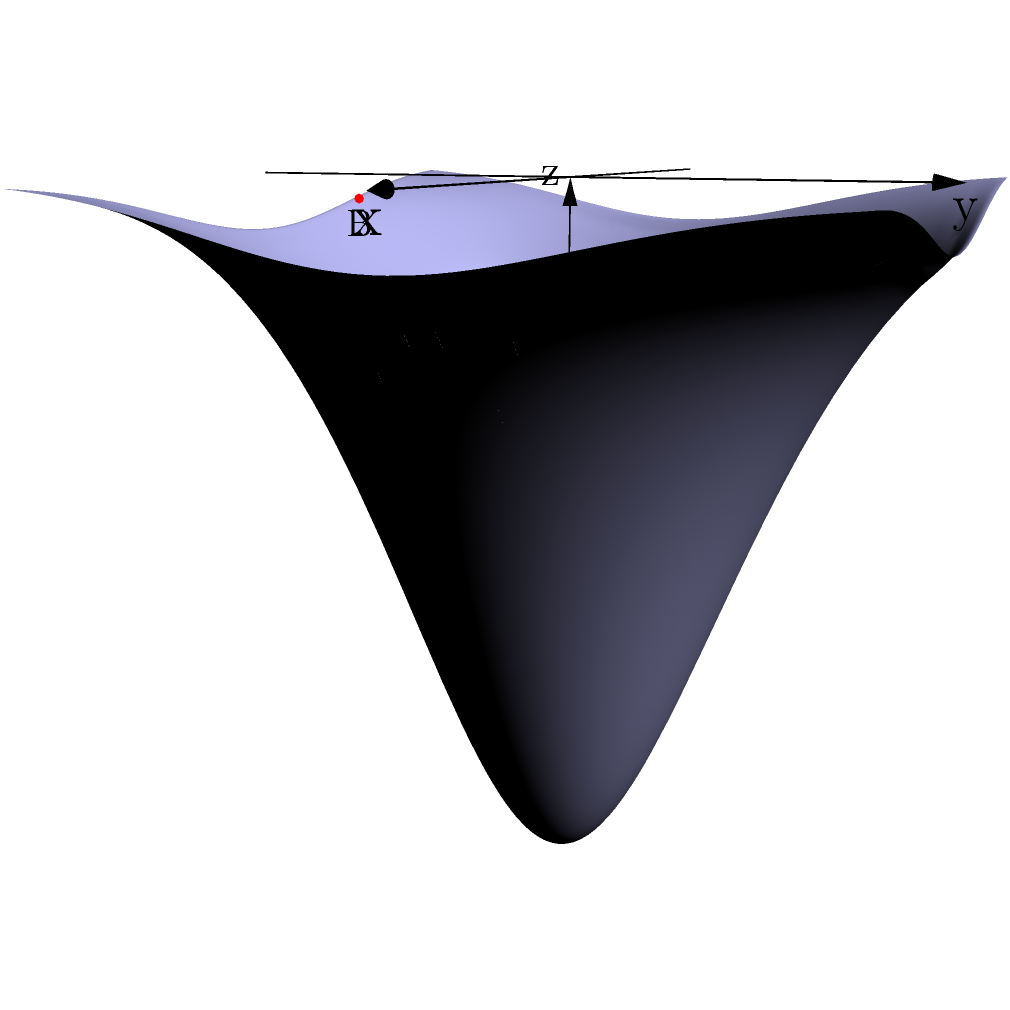In a joint Australian-New Zealand oceanographic survey of the Tasman Sea, two underwater features are discovered at points A(3, 2, -0.11) and B(-1, -4, -0.02) in a 3D coordinate system. The z-axis represents depth in kilometers below sea level, while the x and y axes represent east-west and north-south directions respectively, measured in hundreds of kilometers from the origin. What is the straight-line distance between these two features in kilometers? To find the straight-line distance between two points in 3D space, we can use the distance formula derived from the Pythagorean theorem in three dimensions:

$d = \sqrt{(x_2-x_1)^2 + (y_2-y_1)^2 + (z_2-z_1)^2}$

Where $(x_1,y_1,z_1)$ are the coordinates of point A and $(x_2,y_2,z_2)$ are the coordinates of point B.

Let's follow these steps:

1) Identify the coordinates:
   Point A: (3, 2, -0.11)
   Point B: (-1, -4, -0.02)

2) Calculate the differences:
   $x_2 - x_1 = -1 - 3 = -4$
   $y_2 - y_1 = -4 - 2 = -6$
   $z_2 - z_1 = -0.02 - (-0.11) = 0.09$

3) Square these differences:
   $(-4)^2 = 16$
   $(-6)^2 = 36$
   $(0.09)^2 = 0.0081$

4) Sum the squared differences:
   $16 + 36 + 0.0081 = 52.0081$

5) Take the square root:
   $\sqrt{52.0081} \approx 7.21$

6) Convert to kilometers:
   Since x and y were in hundreds of kilometers, we need to multiply by 100:
   $7.21 * 100 = 721$ kilometers

Thus, the straight-line distance between the two underwater features is approximately 721 kilometers.
Answer: 721 km 